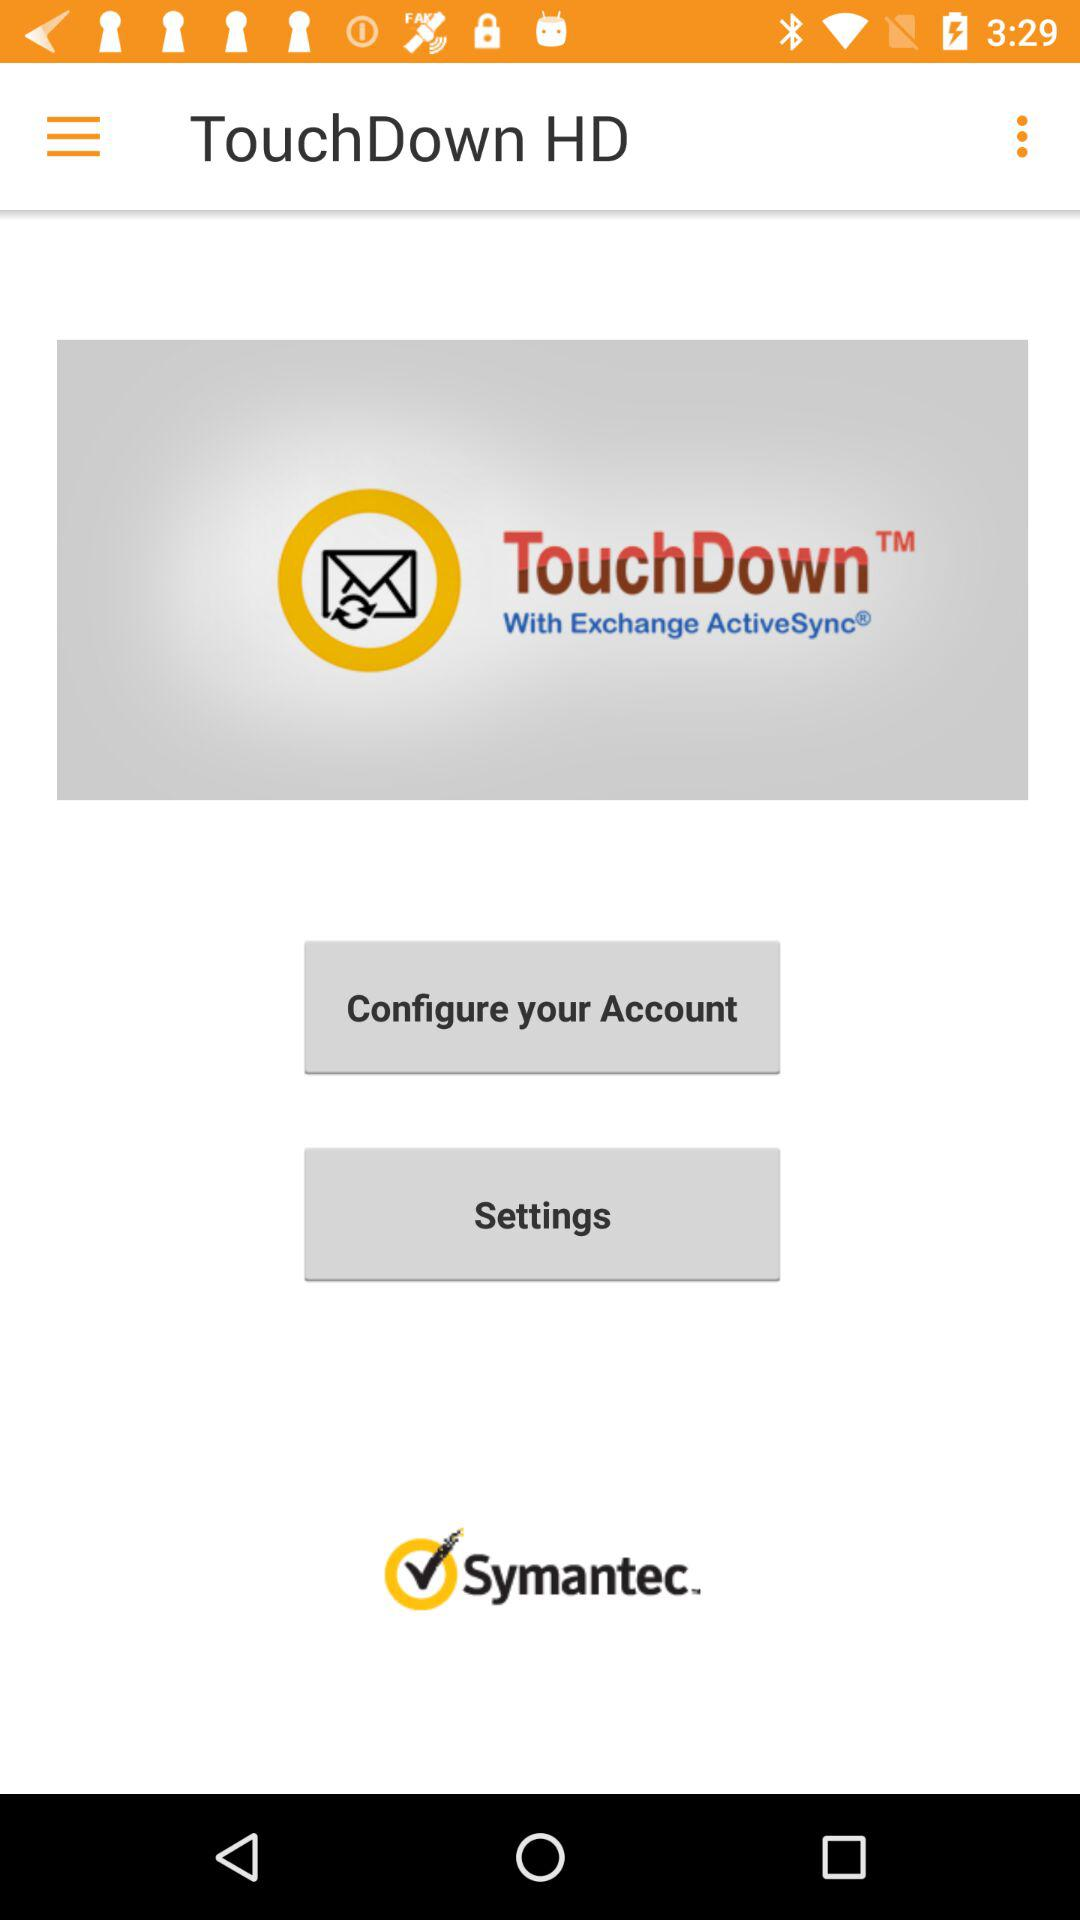What is the name of the application? The name of the application is "TouchDown". 